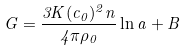<formula> <loc_0><loc_0><loc_500><loc_500>G = \frac { 3 K ( c _ { 0 } ) ^ { 2 } n } { 4 \pi \rho _ { 0 } } \ln a + B</formula> 